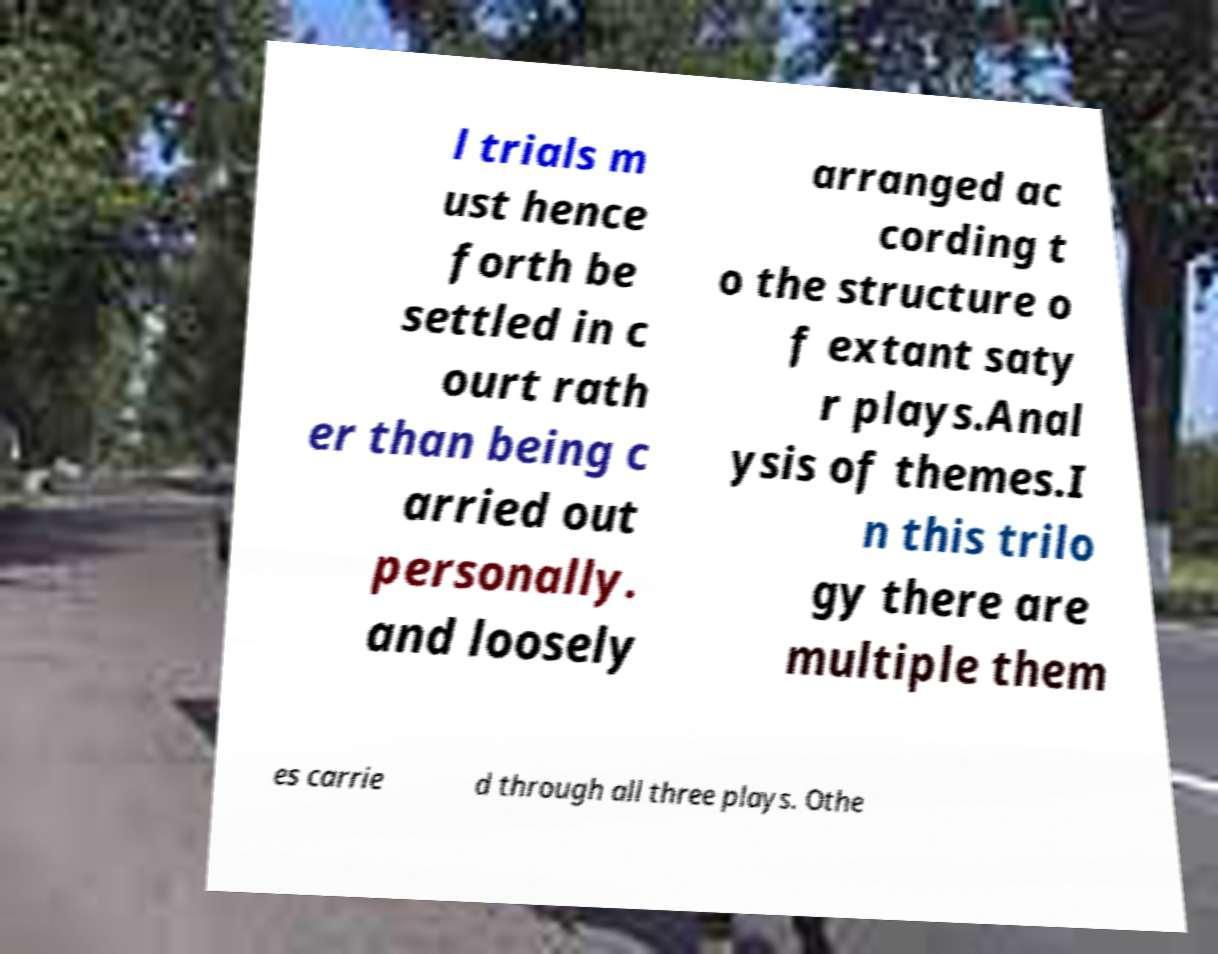Please read and relay the text visible in this image. What does it say? l trials m ust hence forth be settled in c ourt rath er than being c arried out personally. and loosely arranged ac cording t o the structure o f extant saty r plays.Anal ysis of themes.I n this trilo gy there are multiple them es carrie d through all three plays. Othe 